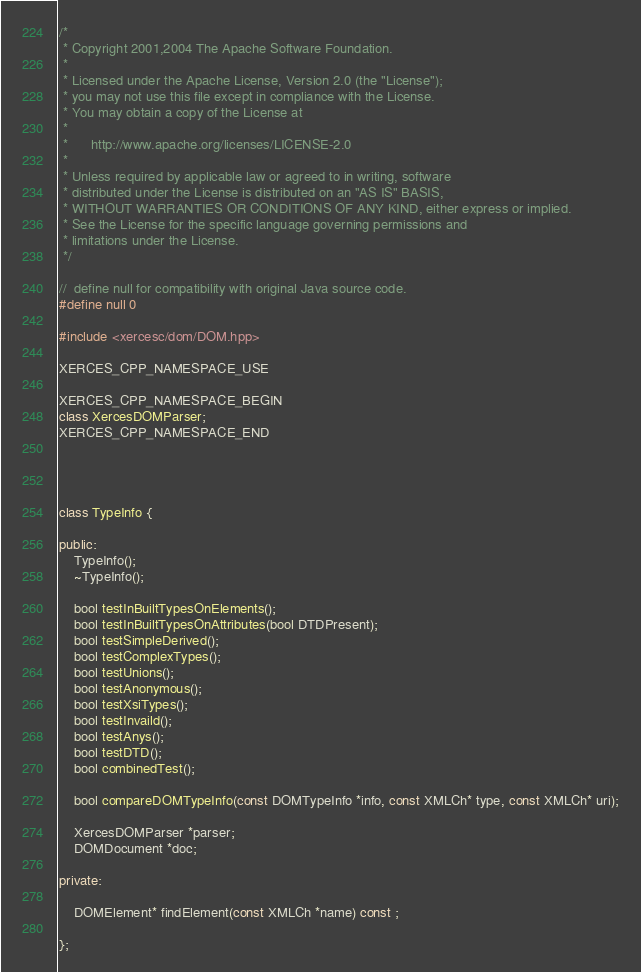<code> <loc_0><loc_0><loc_500><loc_500><_C++_>/*
 * Copyright 2001,2004 The Apache Software Foundation.
 * 
 * Licensed under the Apache License, Version 2.0 (the "License");
 * you may not use this file except in compliance with the License.
 * You may obtain a copy of the License at
 * 
 *      http://www.apache.org/licenses/LICENSE-2.0
 * 
 * Unless required by applicable law or agreed to in writing, software
 * distributed under the License is distributed on an "AS IS" BASIS,
 * WITHOUT WARRANTIES OR CONDITIONS OF ANY KIND, either express or implied.
 * See the License for the specific language governing permissions and
 * limitations under the License.
 */

//  define null for compatibility with original Java source code.
#define null 0

#include <xercesc/dom/DOM.hpp>

XERCES_CPP_NAMESPACE_USE

XERCES_CPP_NAMESPACE_BEGIN
class XercesDOMParser;
XERCES_CPP_NAMESPACE_END




class TypeInfo {

public:
	TypeInfo();
	~TypeInfo();

    bool testInBuiltTypesOnElements();
    bool testInBuiltTypesOnAttributes(bool DTDPresent);
    bool testSimpleDerived();
    bool testComplexTypes();
    bool testUnions();
    bool testAnonymous();
    bool testXsiTypes();
    bool testInvaild();
    bool testAnys();
    bool testDTD();
    bool combinedTest();

    bool compareDOMTypeInfo(const DOMTypeInfo *info, const XMLCh* type, const XMLCh* uri);

	XercesDOMParser *parser;
    DOMDocument *doc;

private:

    DOMElement* findElement(const XMLCh *name) const ;

};
</code> 